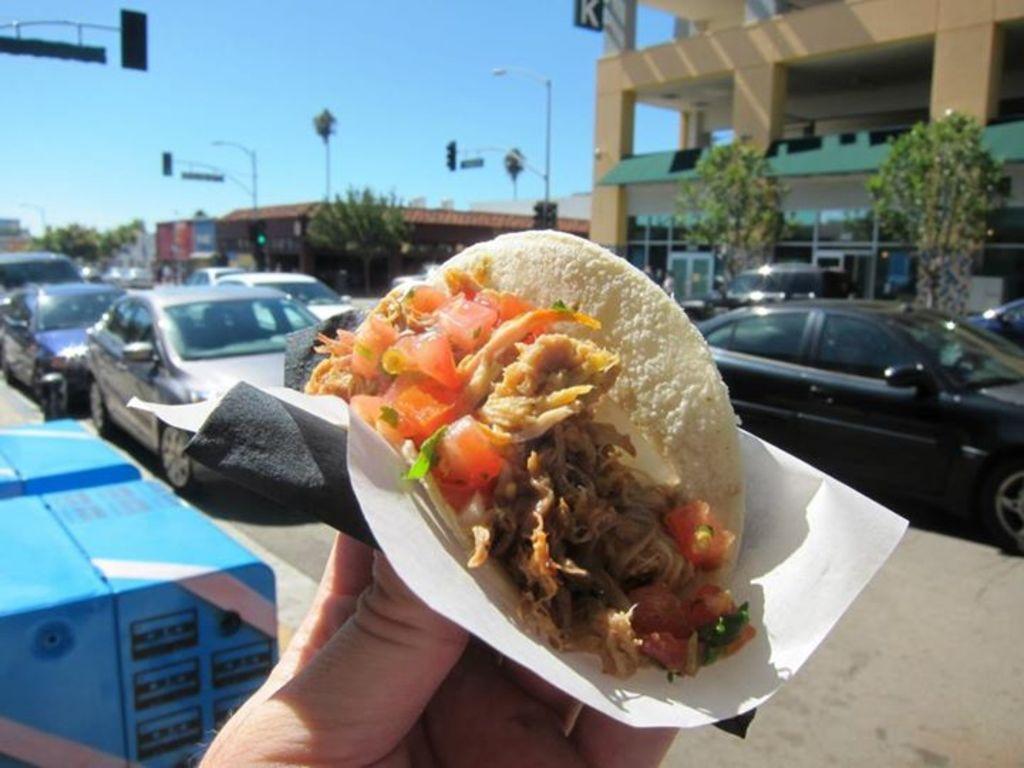Describe this image in one or two sentences. In this image I can see at the bottom a human hand is holding the food, in the middle there are vehicles on the road, in the background there are trees and buildings. At the top there is the sky. 